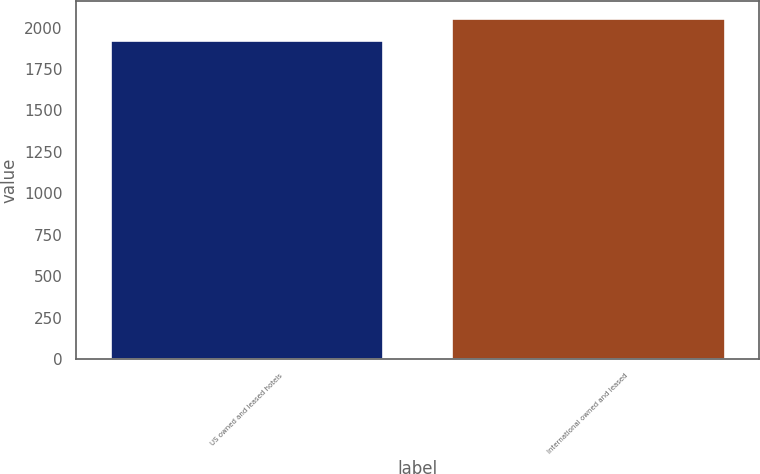Convert chart. <chart><loc_0><loc_0><loc_500><loc_500><bar_chart><fcel>US owned and leased hotels<fcel>International owned and leased<nl><fcel>1922<fcel>2057<nl></chart> 